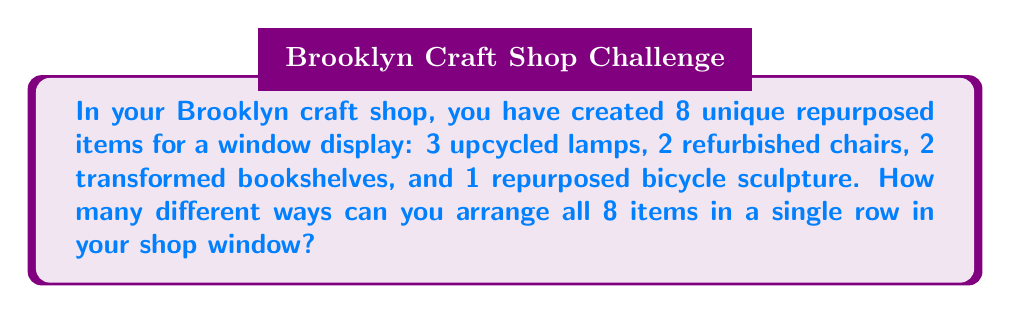Provide a solution to this math problem. To solve this problem, we need to consider the concept of permutations. Since we are arranging all 8 items and the order matters, we are dealing with a permutation problem.

However, this is not a straightforward permutation of 8 distinct items. We have repeated items within our set:
- 3 upcycled lamps (identical)
- 2 refurbished chairs (identical)
- 2 transformed bookshelves (identical)
- 1 repurposed bicycle sculpture (unique)

This scenario calls for the use of the permutation formula with repetition:

$$ \text{Number of permutations} = \frac{n!}{n_1! \cdot n_2! \cdot ... \cdot n_k!} $$

Where:
$n$ = total number of items
$n_1, n_2, ..., n_k$ = number of each type of identical item

In our case:
$n = 8$ (total items)
$n_1 = 3$ (lamps)
$n_2 = 2$ (chairs)
$n_3 = 2$ (bookshelves)
$n_4 = 1$ (bicycle sculpture)

Plugging these values into our formula:

$$ \text{Number of permutations} = \frac{8!}{3! \cdot 2! \cdot 2! \cdot 1!} $$

Let's calculate this step-by-step:

1) $8! = 40,320$
2) $3! = 6$
3) $2! = 2$
4) $1! = 1$

$$ \text{Number of permutations} = \frac{40,320}{6 \cdot 2 \cdot 2 \cdot 1} = \frac{40,320}{24} = 1,680 $$

Therefore, there are 1,680 different ways to arrange the 8 repurposed items in the shop window.
Answer: 1,680 different arrangements 